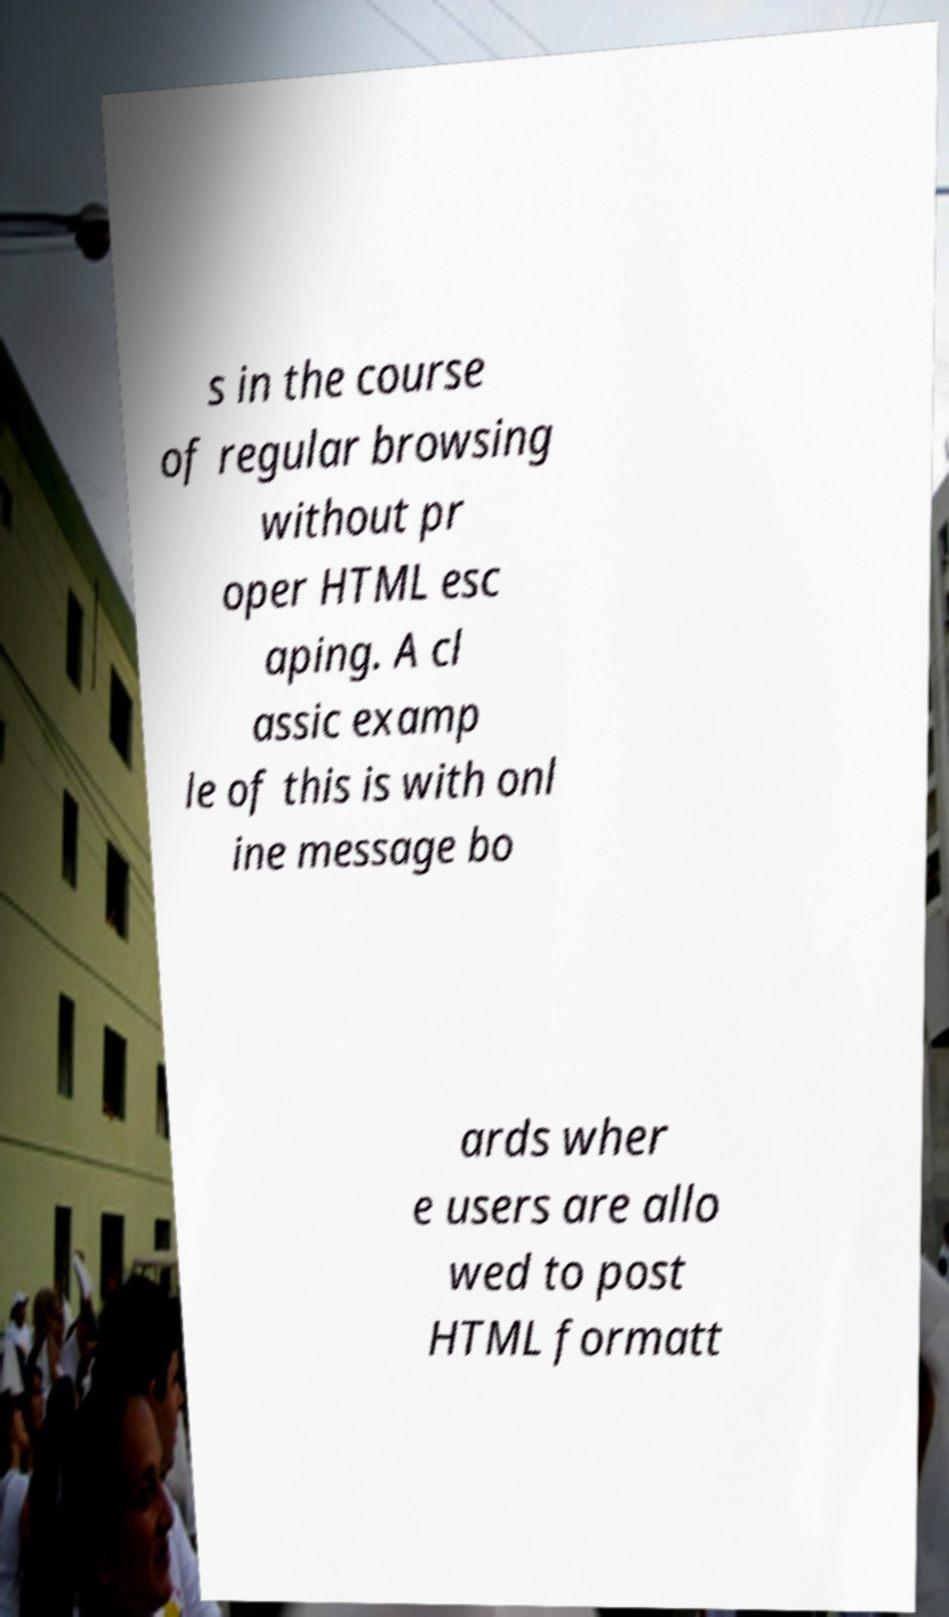Please identify and transcribe the text found in this image. s in the course of regular browsing without pr oper HTML esc aping. A cl assic examp le of this is with onl ine message bo ards wher e users are allo wed to post HTML formatt 